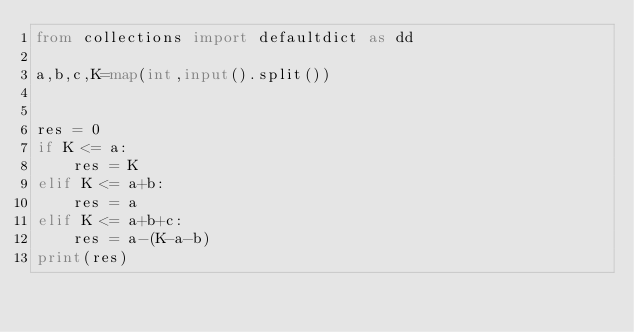Convert code to text. <code><loc_0><loc_0><loc_500><loc_500><_Python_>from collections import defaultdict as dd

a,b,c,K=map(int,input().split())


res = 0
if K <= a:
    res = K
elif K <= a+b:
    res = a
elif K <= a+b+c:
    res = a-(K-a-b)
print(res)
</code> 